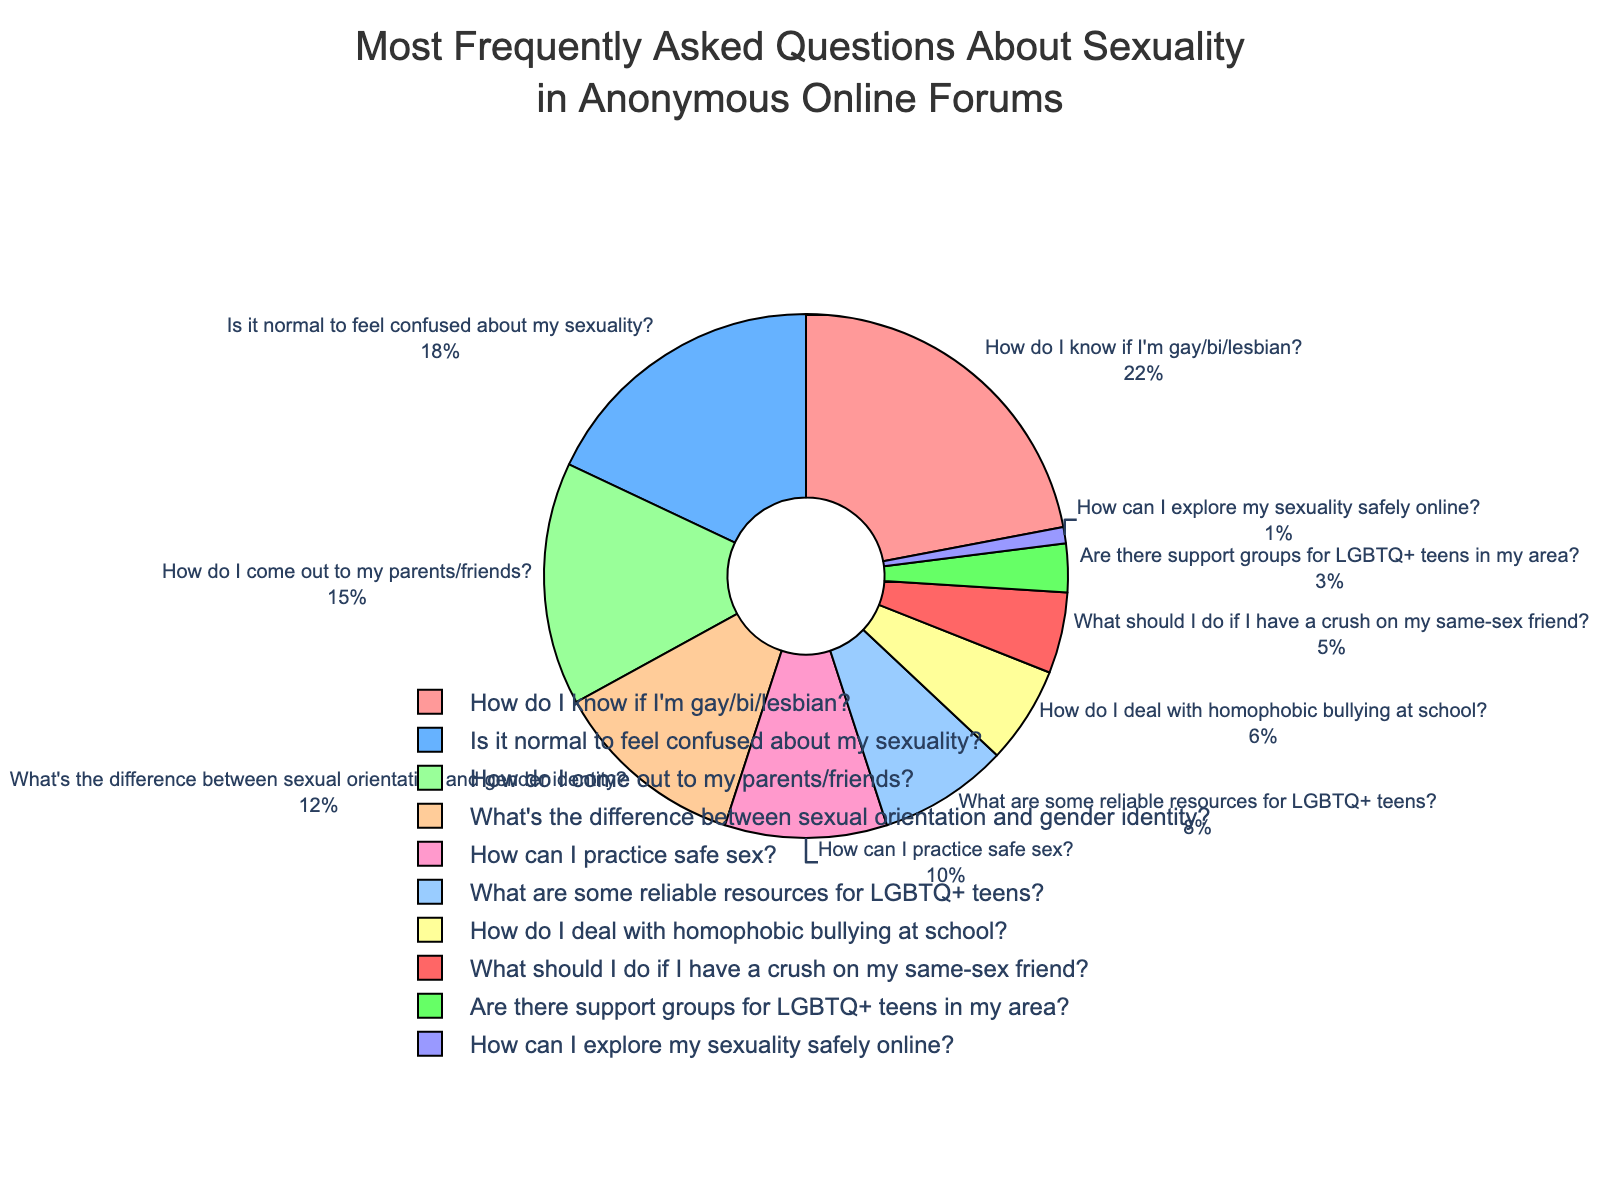What percent of questions are about figuring out one's sexual orientation (e.g., "How do I know if I'm gay/bi/lesbian?" and "Is it normal to feel confused about my sexuality?")? To find this, sum the percentages of the relevant topics: 22% (How do I know if I'm gay/bi/lesbian?) + 18% (Is it normal to feel confused about my sexuality?). Thus, the combined percentage is 22 + 18 = 40%.
Answer: 40% Which question is asked more frequently: "How do I come out to my parents/friends?" or "What's the difference between sexual orientation and gender identity?"? From the figure, the percentage for "How do I come out to my parents/friends?" is 15%, and for "What's the difference between sexual orientation and gender identity?" it is 12%. Comparing these values, 15% is greater than 12%.
Answer: "How do I come out to my parents/friends?" What is the percentage difference between the most frequently asked question and the least frequently asked question? The most frequently asked question has a percentage of 22% ("How do I know if I'm gay/bi/lesbian?"), and the least frequently asked question has a percentage of 1% ("How can I explore my sexuality safely online?"). The percentage difference is calculated as 22% - 1% = 21%.
Answer: 21% If we combine the percentages of questions about coming out and dealing with homophobic bullying, what proportion of the total do they represent? Sum the percentages of "How do I come out to my parents/friends?" (15%) and "How do I deal with homophobic bullying at school?" (6%). The combined total is 15 + 6 = 21%.
Answer: 21% Which color represents the least frequently asked question on the pie chart? In the pie chart generated by the provided code, the least frequently asked question "How can I explore my sexuality safely online?" at 1% is represented by a color. By observing the colors and their labels, it corresponds to light purple.
Answer: Light purple Are questions about practicing safe sex more or less frequently asked compared to questions about reliable resources for LGBTQ+ teens? From the pie chart, the percentage for "How can I practice safe sex?" is 10%, while "What are some reliable resources for LGBTQ+ teens?" is 8%. Comparing these values, 10% is greater than 8%.
Answer: More frequently asked What is the combined percentage of the three least frequently asked questions? The three least frequently asked questions are "How do I deal with homophobic bullying at school?" (6%), "What should I do if I have a crush on my same-sex friend?" (5%), and "Are there support groups for LGBTQ+ teens in my area?" (3%). Adding these up: 6 + 5 + 3 = 14%.
Answer: 14% How many questions are represented in the pie chart with a percentage of 10% or greater? By examining the pie chart, the questions with percentages of 10% or greater are: "How do I know if I'm gay/bi/lesbian?" (22%), "Is it normal to feel confused about my sexuality?" (18%), "How do I come out to my parents/friends?" (15%), "What's the difference between sexual orientation and gender identity?" (12%), and "How can I practice safe sex?" (10%). Therefore, there are 5 such questions.
Answer: 5 